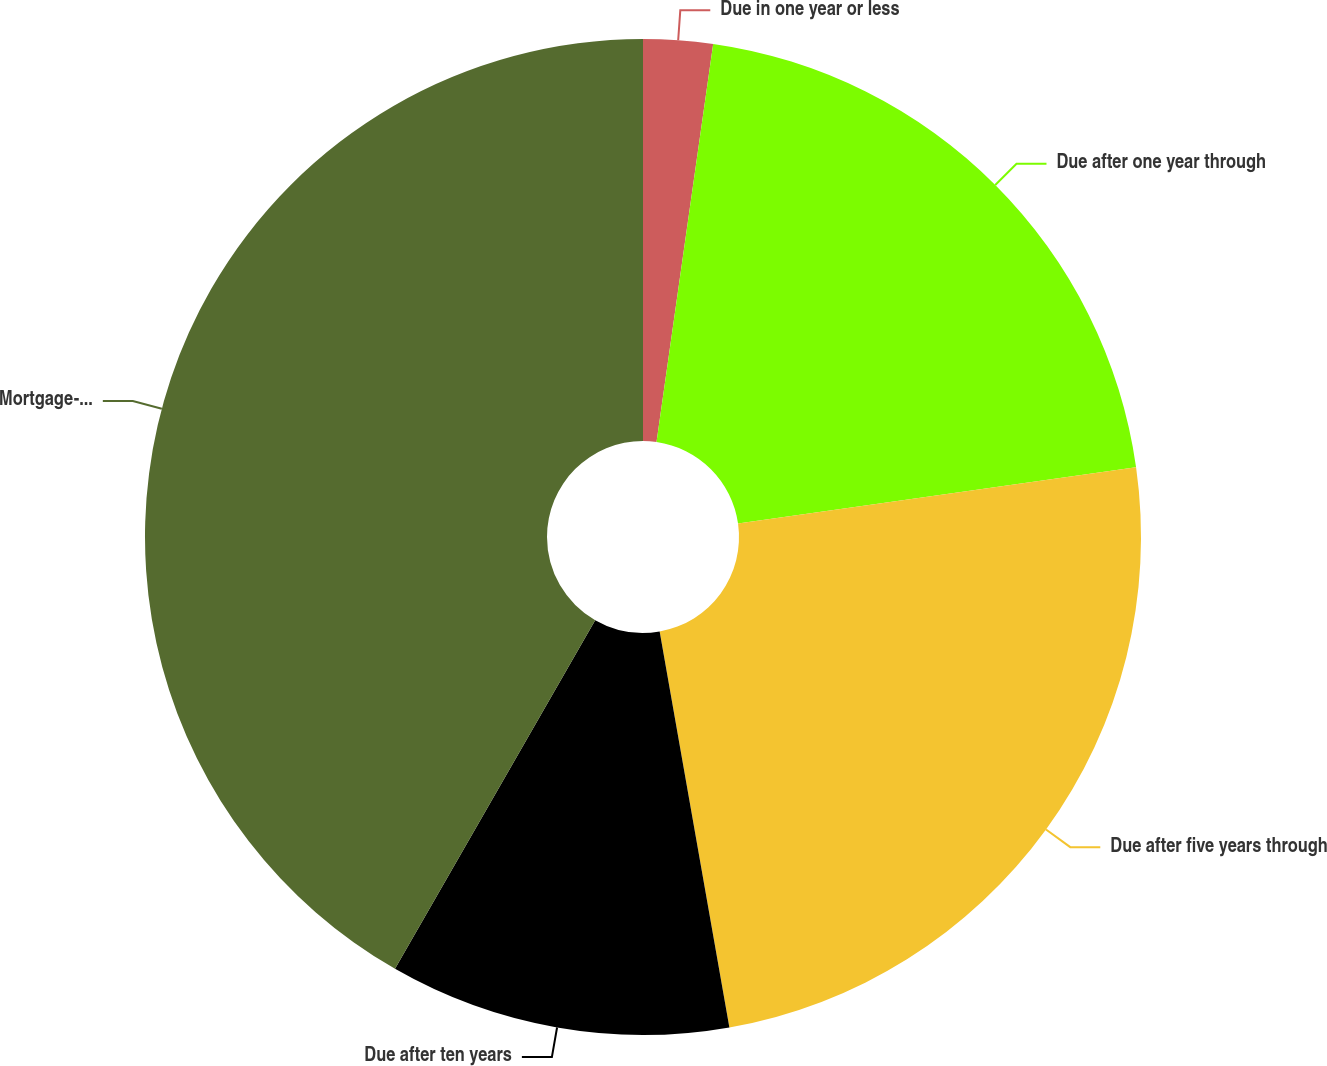Convert chart. <chart><loc_0><loc_0><loc_500><loc_500><pie_chart><fcel>Due in one year or less<fcel>Due after one year through<fcel>Due after five years through<fcel>Due after ten years<fcel>Mortgage-backed securities<nl><fcel>2.25%<fcel>20.51%<fcel>24.46%<fcel>11.07%<fcel>41.7%<nl></chart> 